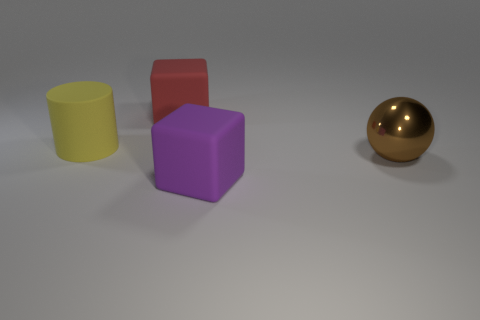What color is the object that is behind the shiny thing and on the right side of the big yellow matte cylinder?
Your response must be concise. Red. There is a big thing on the right side of the large purple rubber thing that is in front of the yellow cylinder; are there any shiny things right of it?
Your answer should be compact. No. There is another thing that is the same shape as the large purple object; what size is it?
Offer a very short reply. Large. Is there anything else that has the same material as the large brown thing?
Ensure brevity in your answer.  No. Are any big red things visible?
Make the answer very short. Yes. What number of other big cylinders have the same color as the matte cylinder?
Keep it short and to the point. 0. What number of objects are large green shiny cylinders or rubber things that are in front of the big shiny sphere?
Make the answer very short. 1. The large ball is what color?
Keep it short and to the point. Brown. There is a rubber cube that is to the left of the purple block; what color is it?
Make the answer very short. Red. How many matte objects are behind the object that is in front of the ball?
Provide a short and direct response. 2. 